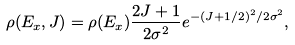Convert formula to latex. <formula><loc_0><loc_0><loc_500><loc_500>\rho ( E _ { x } , J ) = \rho ( E _ { x } ) \frac { 2 J + 1 } { 2 \sigma ^ { 2 } } e ^ { - ( J + 1 / 2 ) ^ { 2 } / 2 \sigma ^ { 2 } } ,</formula> 